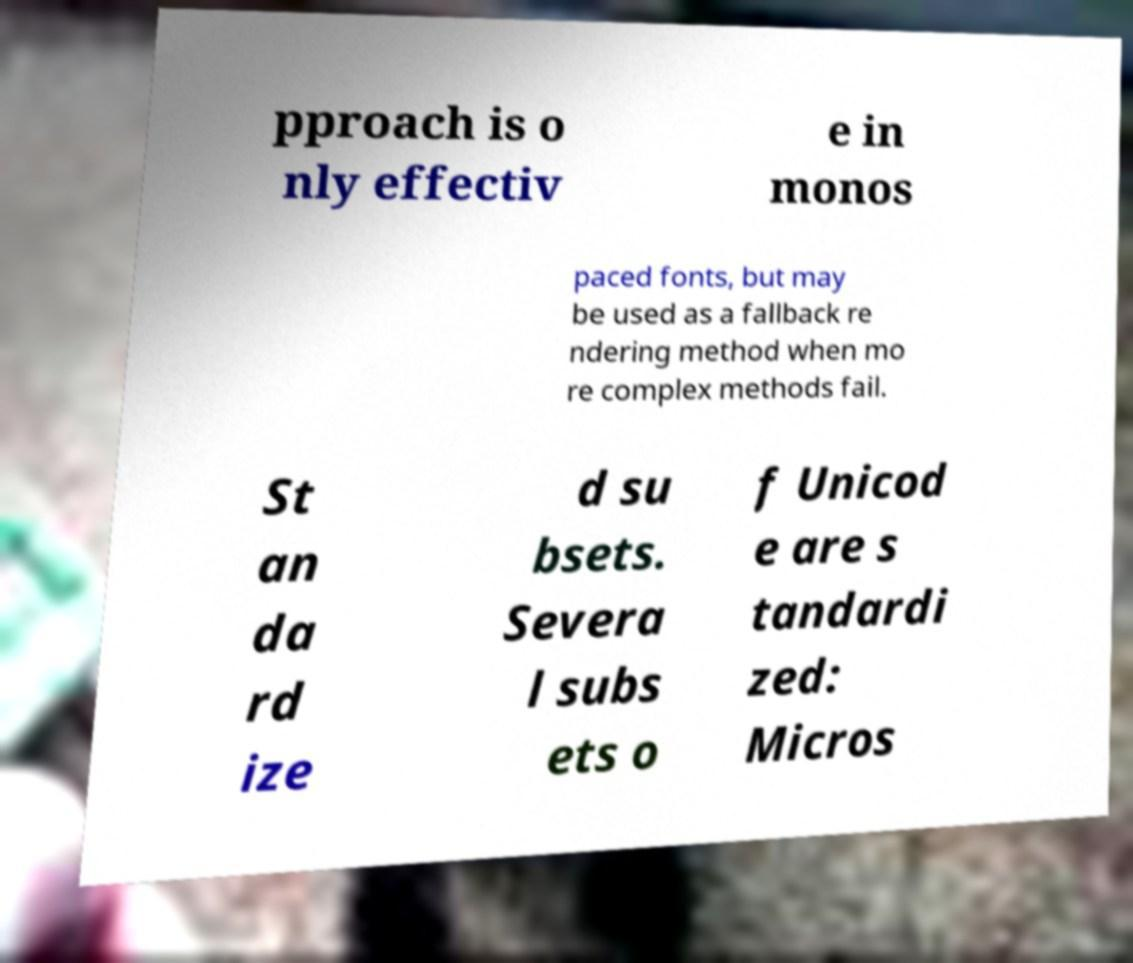Please read and relay the text visible in this image. What does it say? pproach is o nly effectiv e in monos paced fonts, but may be used as a fallback re ndering method when mo re complex methods fail. St an da rd ize d su bsets. Severa l subs ets o f Unicod e are s tandardi zed: Micros 